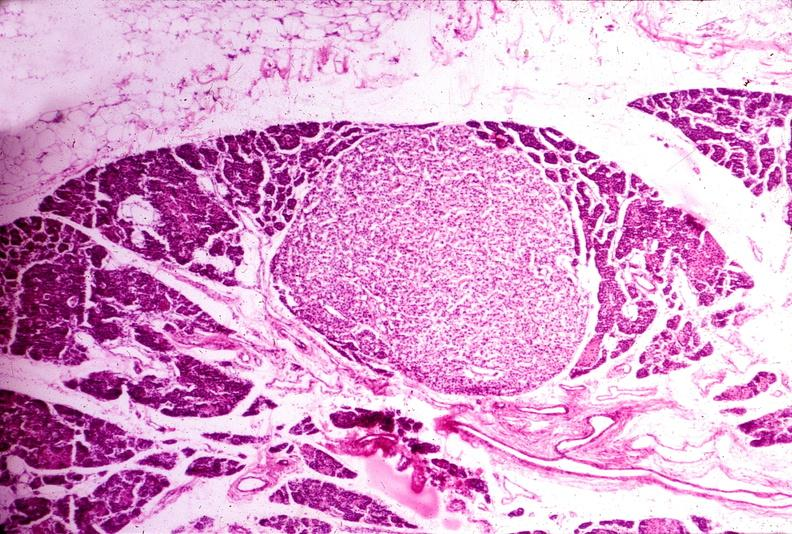does this image show parathyroid adenoma?
Answer the question using a single word or phrase. Yes 